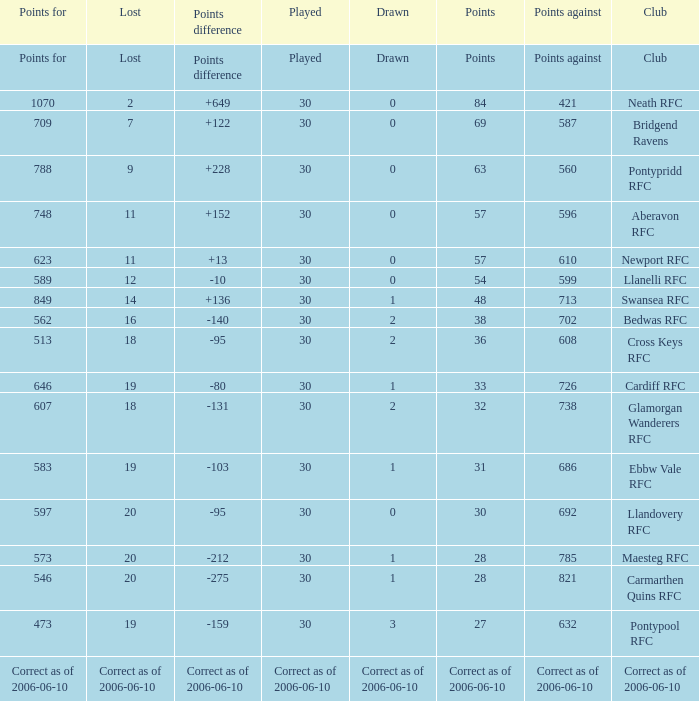What is Points For, when Points is "63"? 788.0. 